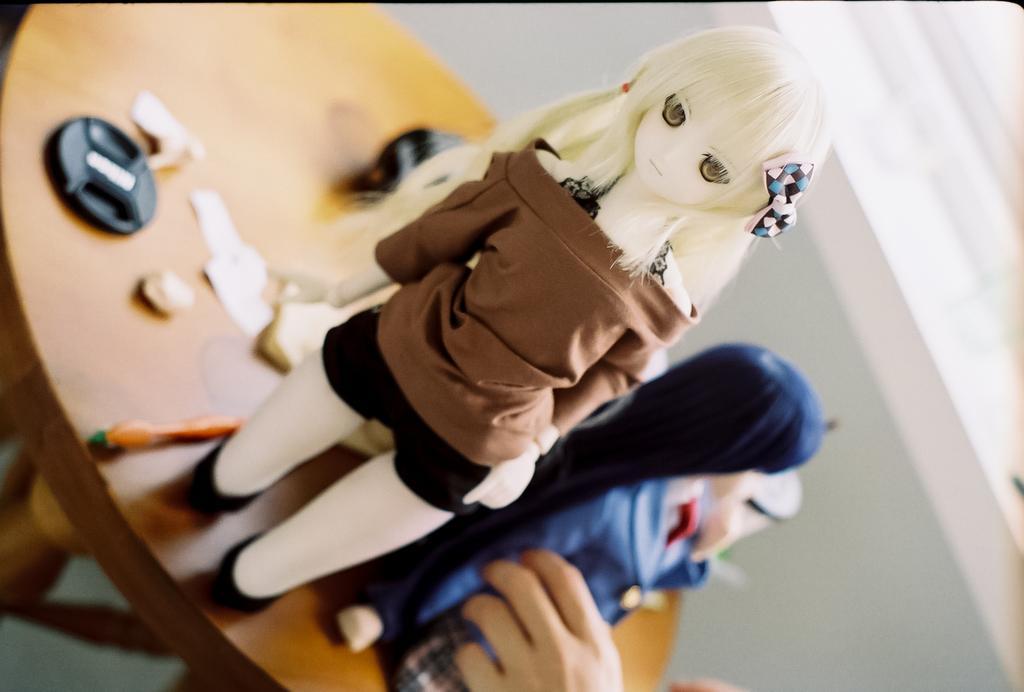Could you give a brief overview of what you see in this image? In this image I can see a table and on it I can see few dollars and few other stuffs. On the bottom side of this image I can see hand of a person and I can also see this image is little bit blurry in the background. 